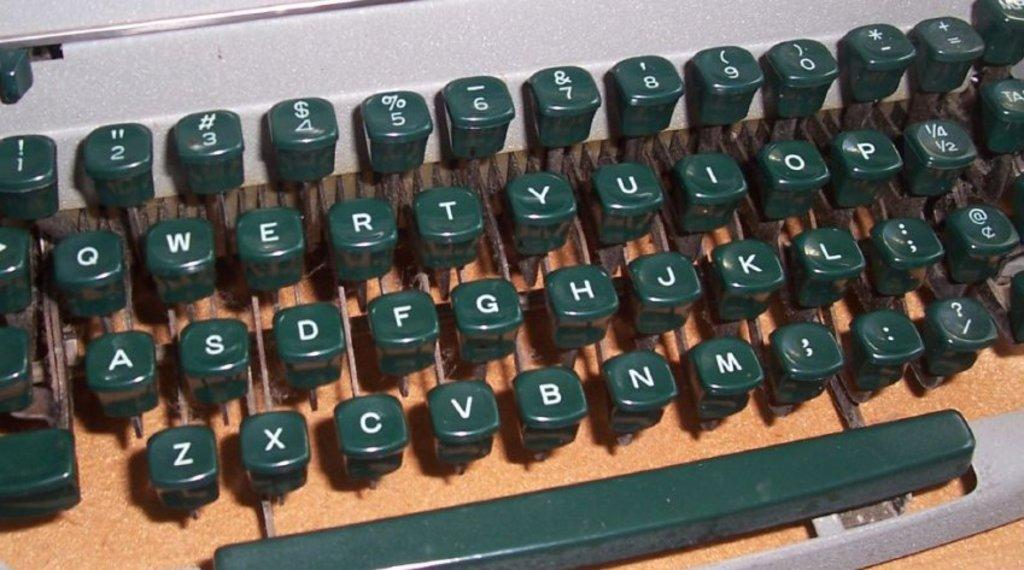<image>
Present a compact description of the photo's key features. A keyboard with letters in the usual QWERTY arrangement. 